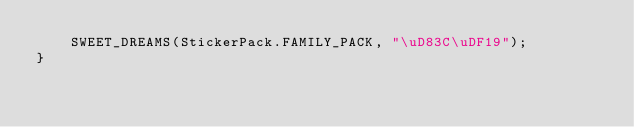<code> <loc_0><loc_0><loc_500><loc_500><_Kotlin_>    SWEET_DREAMS(StickerPack.FAMILY_PACK, "\uD83C\uDF19");
}
</code> 